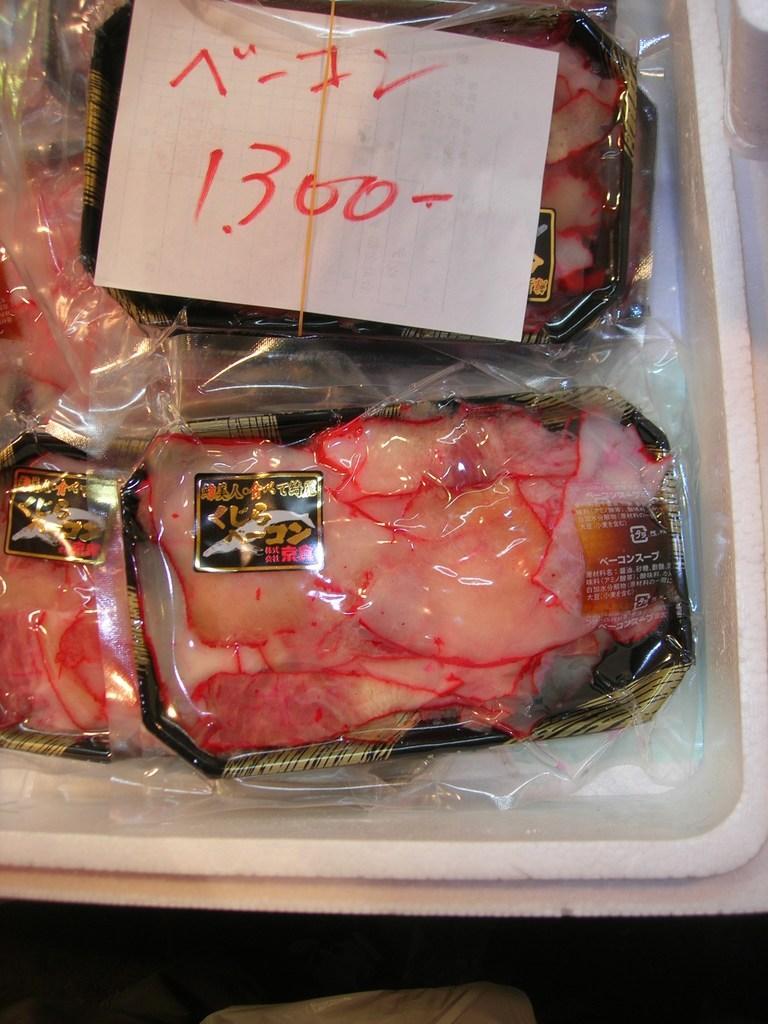Describe this image in one or two sentences. In this image I can see few food boxes covered with plastic cover. They are on white color box. I can see a white paper on it. 